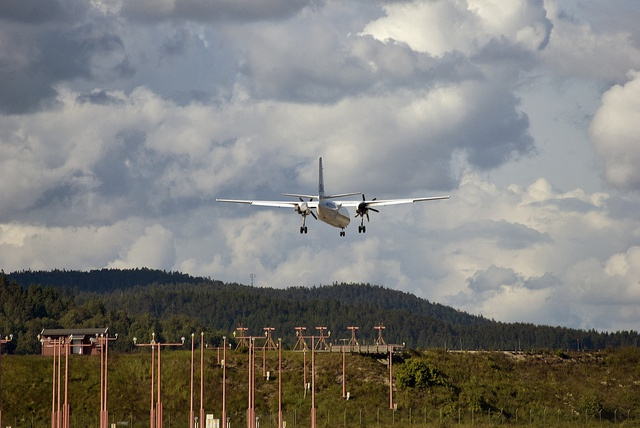Describe the objects in this image and their specific colors. I can see a airplane in gray, darkgray, white, and black tones in this image. 